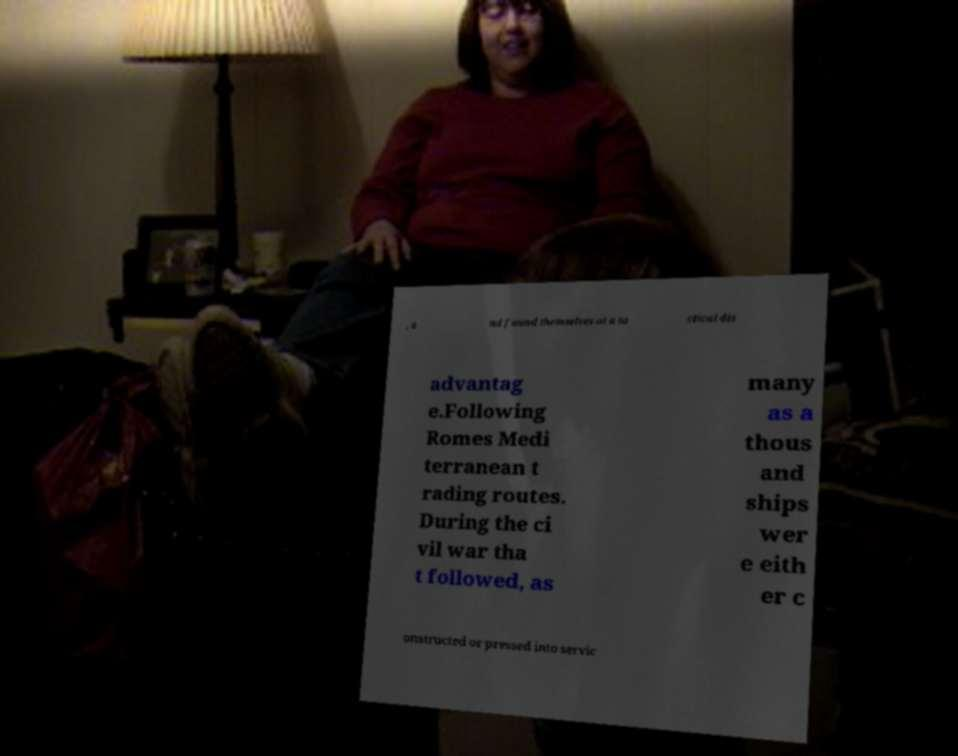For documentation purposes, I need the text within this image transcribed. Could you provide that? , a nd found themselves at a ta ctical dis advantag e.Following Romes Medi terranean t rading routes. During the ci vil war tha t followed, as many as a thous and ships wer e eith er c onstructed or pressed into servic 